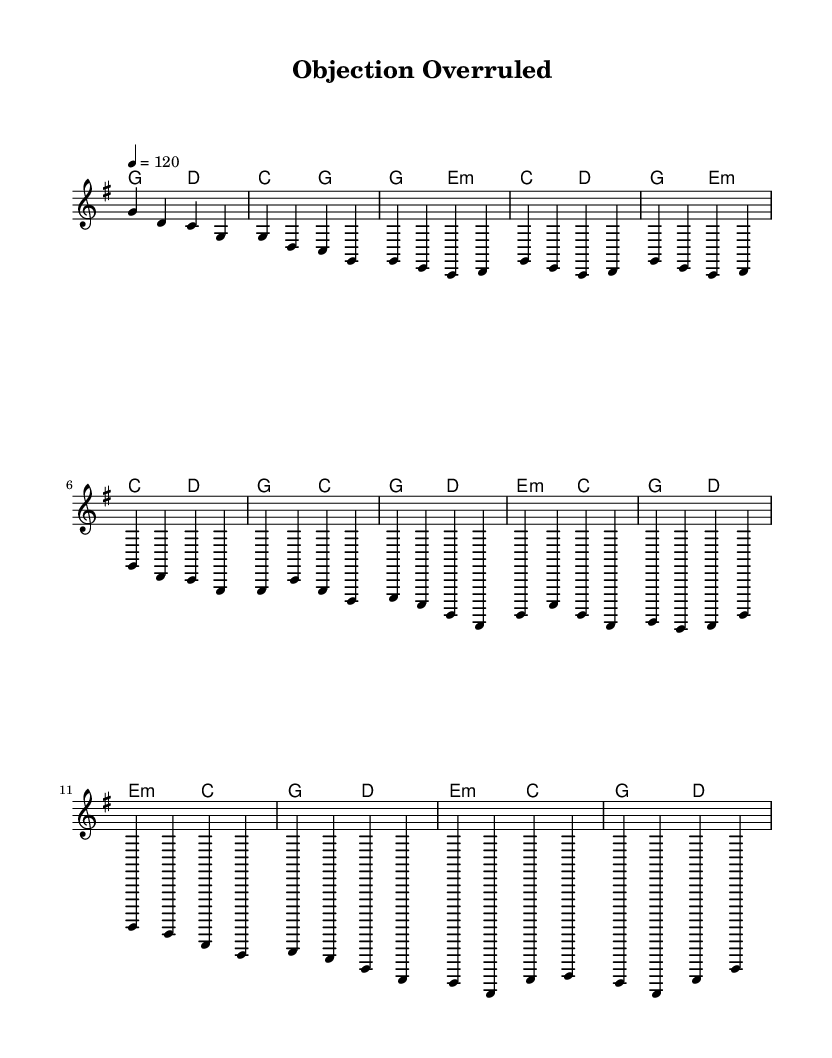What is the key signature of this music? The key signature is G major, which has one sharp (F#). This can be inferred from the context indicated in the global settings at the beginning of the code.
Answer: G major What is the time signature of this piece? The time signature is 4/4, which is also specified in the global settings section. It indicates that there are four beats in each measure and the quarter note gets one beat.
Answer: 4/4 What is the tempo marking for this music? The tempo is marked at 120 beats per minute, indicated by the line "4 = 120" in the global section. This means the quarter note is played at a rate of 120 beats in one minute.
Answer: 120 How many measures are in the chorus? The chorus consists of four measures, as shown in the structured layout of lyrics and melody. Counting the number of measures in the chorus section provides this information.
Answer: Four What is the theme of the lyrics in this piece? The theme reflects legal triumphs and courtroom drama, focusing on concepts like justice, victory, and fighting for rights, which is apparent from the lyrics provided. This thematic content is specific to the context of a courtroom setting.
Answer: Legal triumphs Which chord is used in the bridge section? The bridge section features two primary chords: E minor and C major. These chords provide the harmonic foundation during that part of the song, and their identification can be derived from the harmonies indicated in the code.
Answer: E minor and C major 